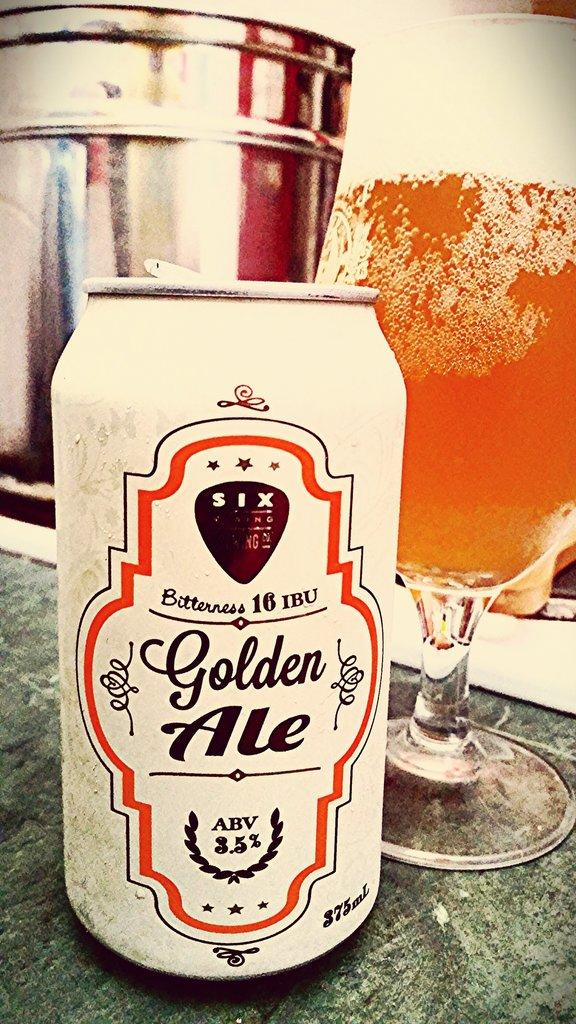<image>
Share a concise interpretation of the image provided. The ABV in the can of Golden Ale is 3.5%. 